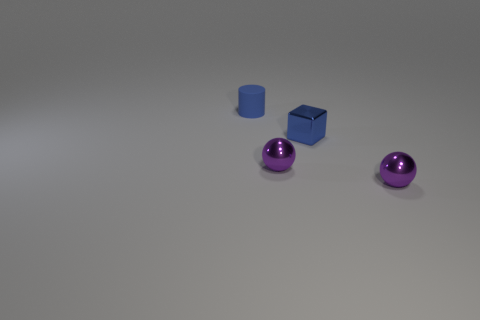Are the blue block and the small purple object that is right of the tiny blue shiny cube made of the same material?
Provide a succinct answer. Yes. There is a metal object that is to the right of the blue object that is on the right side of the tiny blue rubber cylinder; what shape is it?
Offer a very short reply. Sphere. Do the blue object that is on the right side of the blue rubber cylinder and the matte thing have the same size?
Your response must be concise. Yes. How many other objects are the same shape as the small blue rubber object?
Offer a terse response. 0. There is a small cylinder behind the blue shiny cube; does it have the same color as the small block?
Your answer should be compact. Yes. Are there any spheres of the same color as the matte cylinder?
Offer a very short reply. No. How many tiny purple metallic spheres are behind the small cylinder?
Give a very brief answer. 0. How many other objects are there of the same size as the shiny cube?
Ensure brevity in your answer.  3. Is the ball on the right side of the tiny blue metallic block made of the same material as the tiny ball that is on the left side of the blue shiny object?
Provide a succinct answer. Yes. What is the color of the block that is the same size as the matte thing?
Make the answer very short. Blue. 